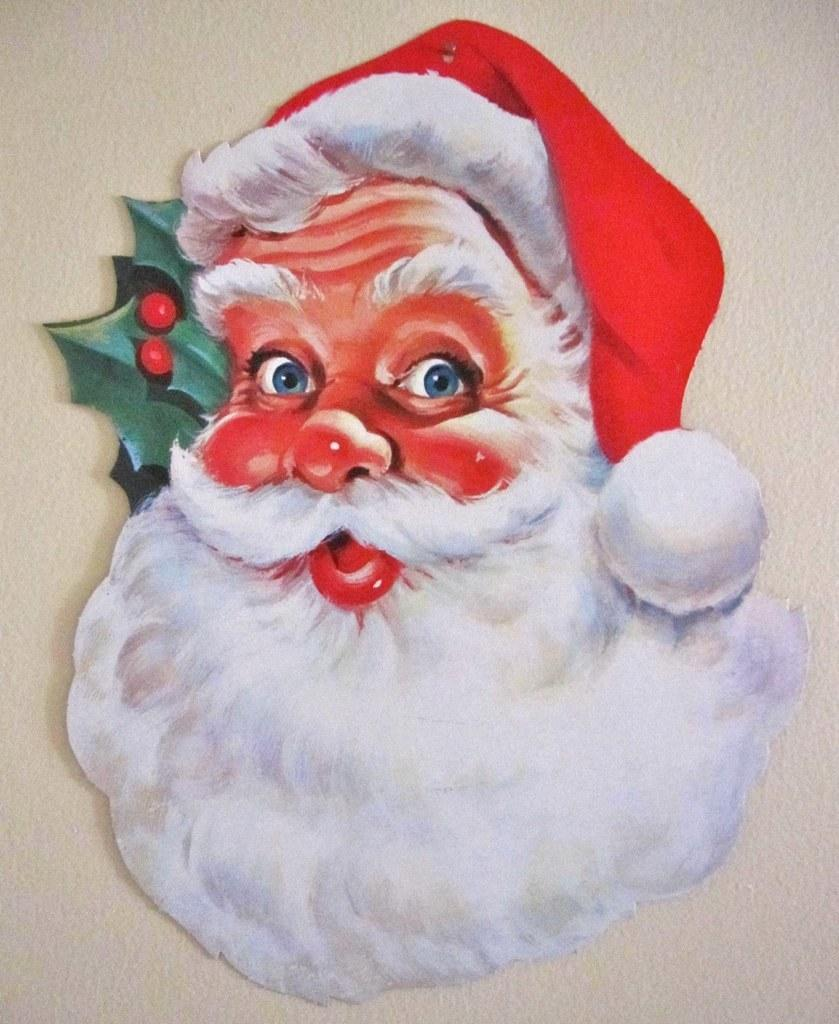What is depicted in the painting in the image? There is a painting of Santa Claus in the image. What type of trail can be seen in the background of the painting? There is no trail visible in the painting, as it features Santa Claus and does not include any background elements. 